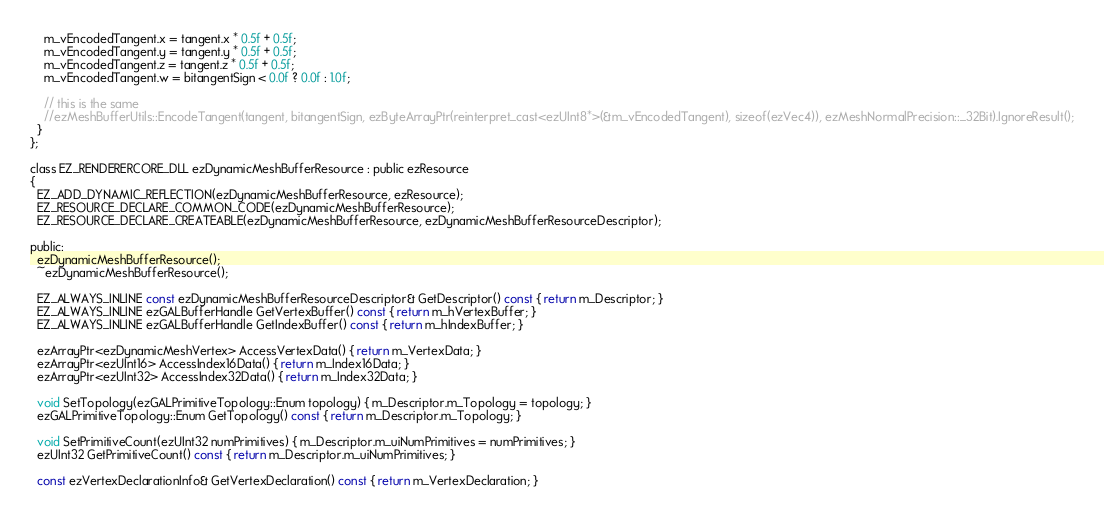Convert code to text. <code><loc_0><loc_0><loc_500><loc_500><_C_>    m_vEncodedTangent.x = tangent.x * 0.5f + 0.5f;
    m_vEncodedTangent.y = tangent.y * 0.5f + 0.5f;
    m_vEncodedTangent.z = tangent.z * 0.5f + 0.5f;
    m_vEncodedTangent.w = bitangentSign < 0.0f ? 0.0f : 1.0f;

    // this is the same
    //ezMeshBufferUtils::EncodeTangent(tangent, bitangentSign, ezByteArrayPtr(reinterpret_cast<ezUInt8*>(&m_vEncodedTangent), sizeof(ezVec4)), ezMeshNormalPrecision::_32Bit).IgnoreResult();
  }
};

class EZ_RENDERERCORE_DLL ezDynamicMeshBufferResource : public ezResource
{
  EZ_ADD_DYNAMIC_REFLECTION(ezDynamicMeshBufferResource, ezResource);
  EZ_RESOURCE_DECLARE_COMMON_CODE(ezDynamicMeshBufferResource);
  EZ_RESOURCE_DECLARE_CREATEABLE(ezDynamicMeshBufferResource, ezDynamicMeshBufferResourceDescriptor);

public:
  ezDynamicMeshBufferResource();
  ~ezDynamicMeshBufferResource();

  EZ_ALWAYS_INLINE const ezDynamicMeshBufferResourceDescriptor& GetDescriptor() const { return m_Descriptor; }
  EZ_ALWAYS_INLINE ezGALBufferHandle GetVertexBuffer() const { return m_hVertexBuffer; }
  EZ_ALWAYS_INLINE ezGALBufferHandle GetIndexBuffer() const { return m_hIndexBuffer; }

  ezArrayPtr<ezDynamicMeshVertex> AccessVertexData() { return m_VertexData; }
  ezArrayPtr<ezUInt16> AccessIndex16Data() { return m_Index16Data; }
  ezArrayPtr<ezUInt32> AccessIndex32Data() { return m_Index32Data; }

  void SetTopology(ezGALPrimitiveTopology::Enum topology) { m_Descriptor.m_Topology = topology; }
  ezGALPrimitiveTopology::Enum GetTopology() const { return m_Descriptor.m_Topology; }

  void SetPrimitiveCount(ezUInt32 numPrimitives) { m_Descriptor.m_uiNumPrimitives = numPrimitives; }
  ezUInt32 GetPrimitiveCount() const { return m_Descriptor.m_uiNumPrimitives; }

  const ezVertexDeclarationInfo& GetVertexDeclaration() const { return m_VertexDeclaration; }
</code> 